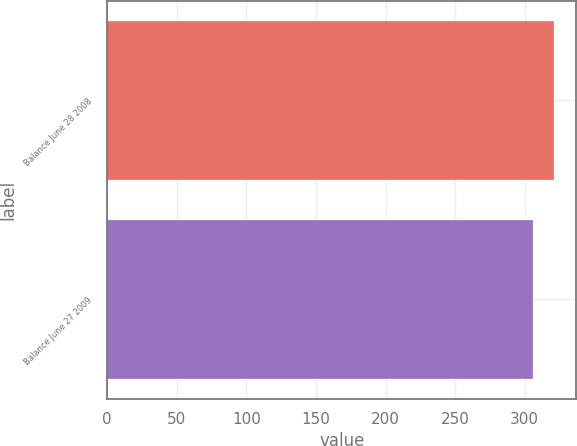Convert chart. <chart><loc_0><loc_0><loc_500><loc_500><bar_chart><fcel>Balance June 28 2008<fcel>Balance June 27 2009<nl><fcel>321<fcel>306<nl></chart> 